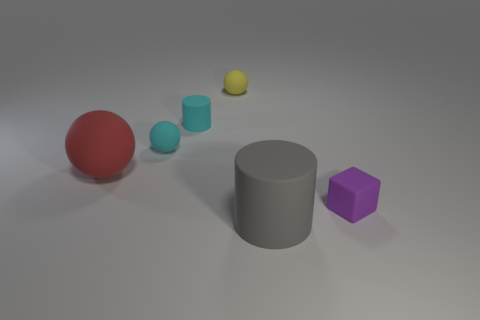Subtract 1 spheres. How many spheres are left? 2 Add 2 large cylinders. How many objects exist? 8 Subtract all cubes. How many objects are left? 5 Add 1 tiny cyan things. How many tiny cyan things exist? 3 Subtract 1 yellow balls. How many objects are left? 5 Subtract all large objects. Subtract all large purple matte things. How many objects are left? 4 Add 5 small rubber cubes. How many small rubber cubes are left? 6 